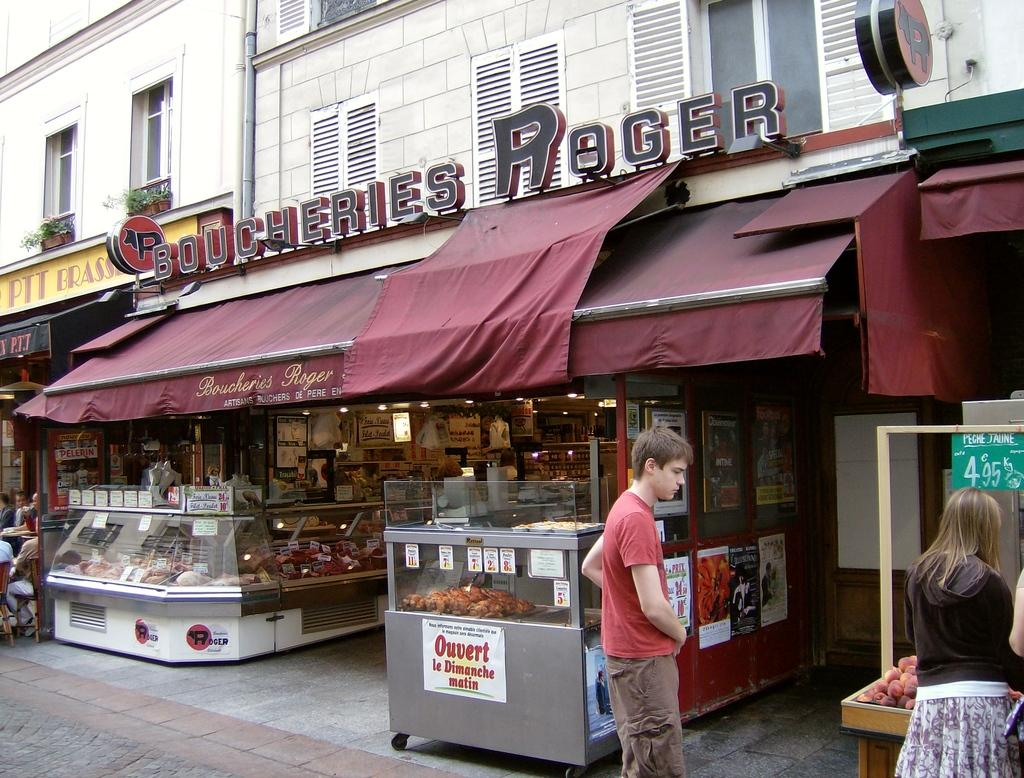<image>
Describe the image concisely. The shop shown is a Boucheries Roger shop selling cuts of meat. 